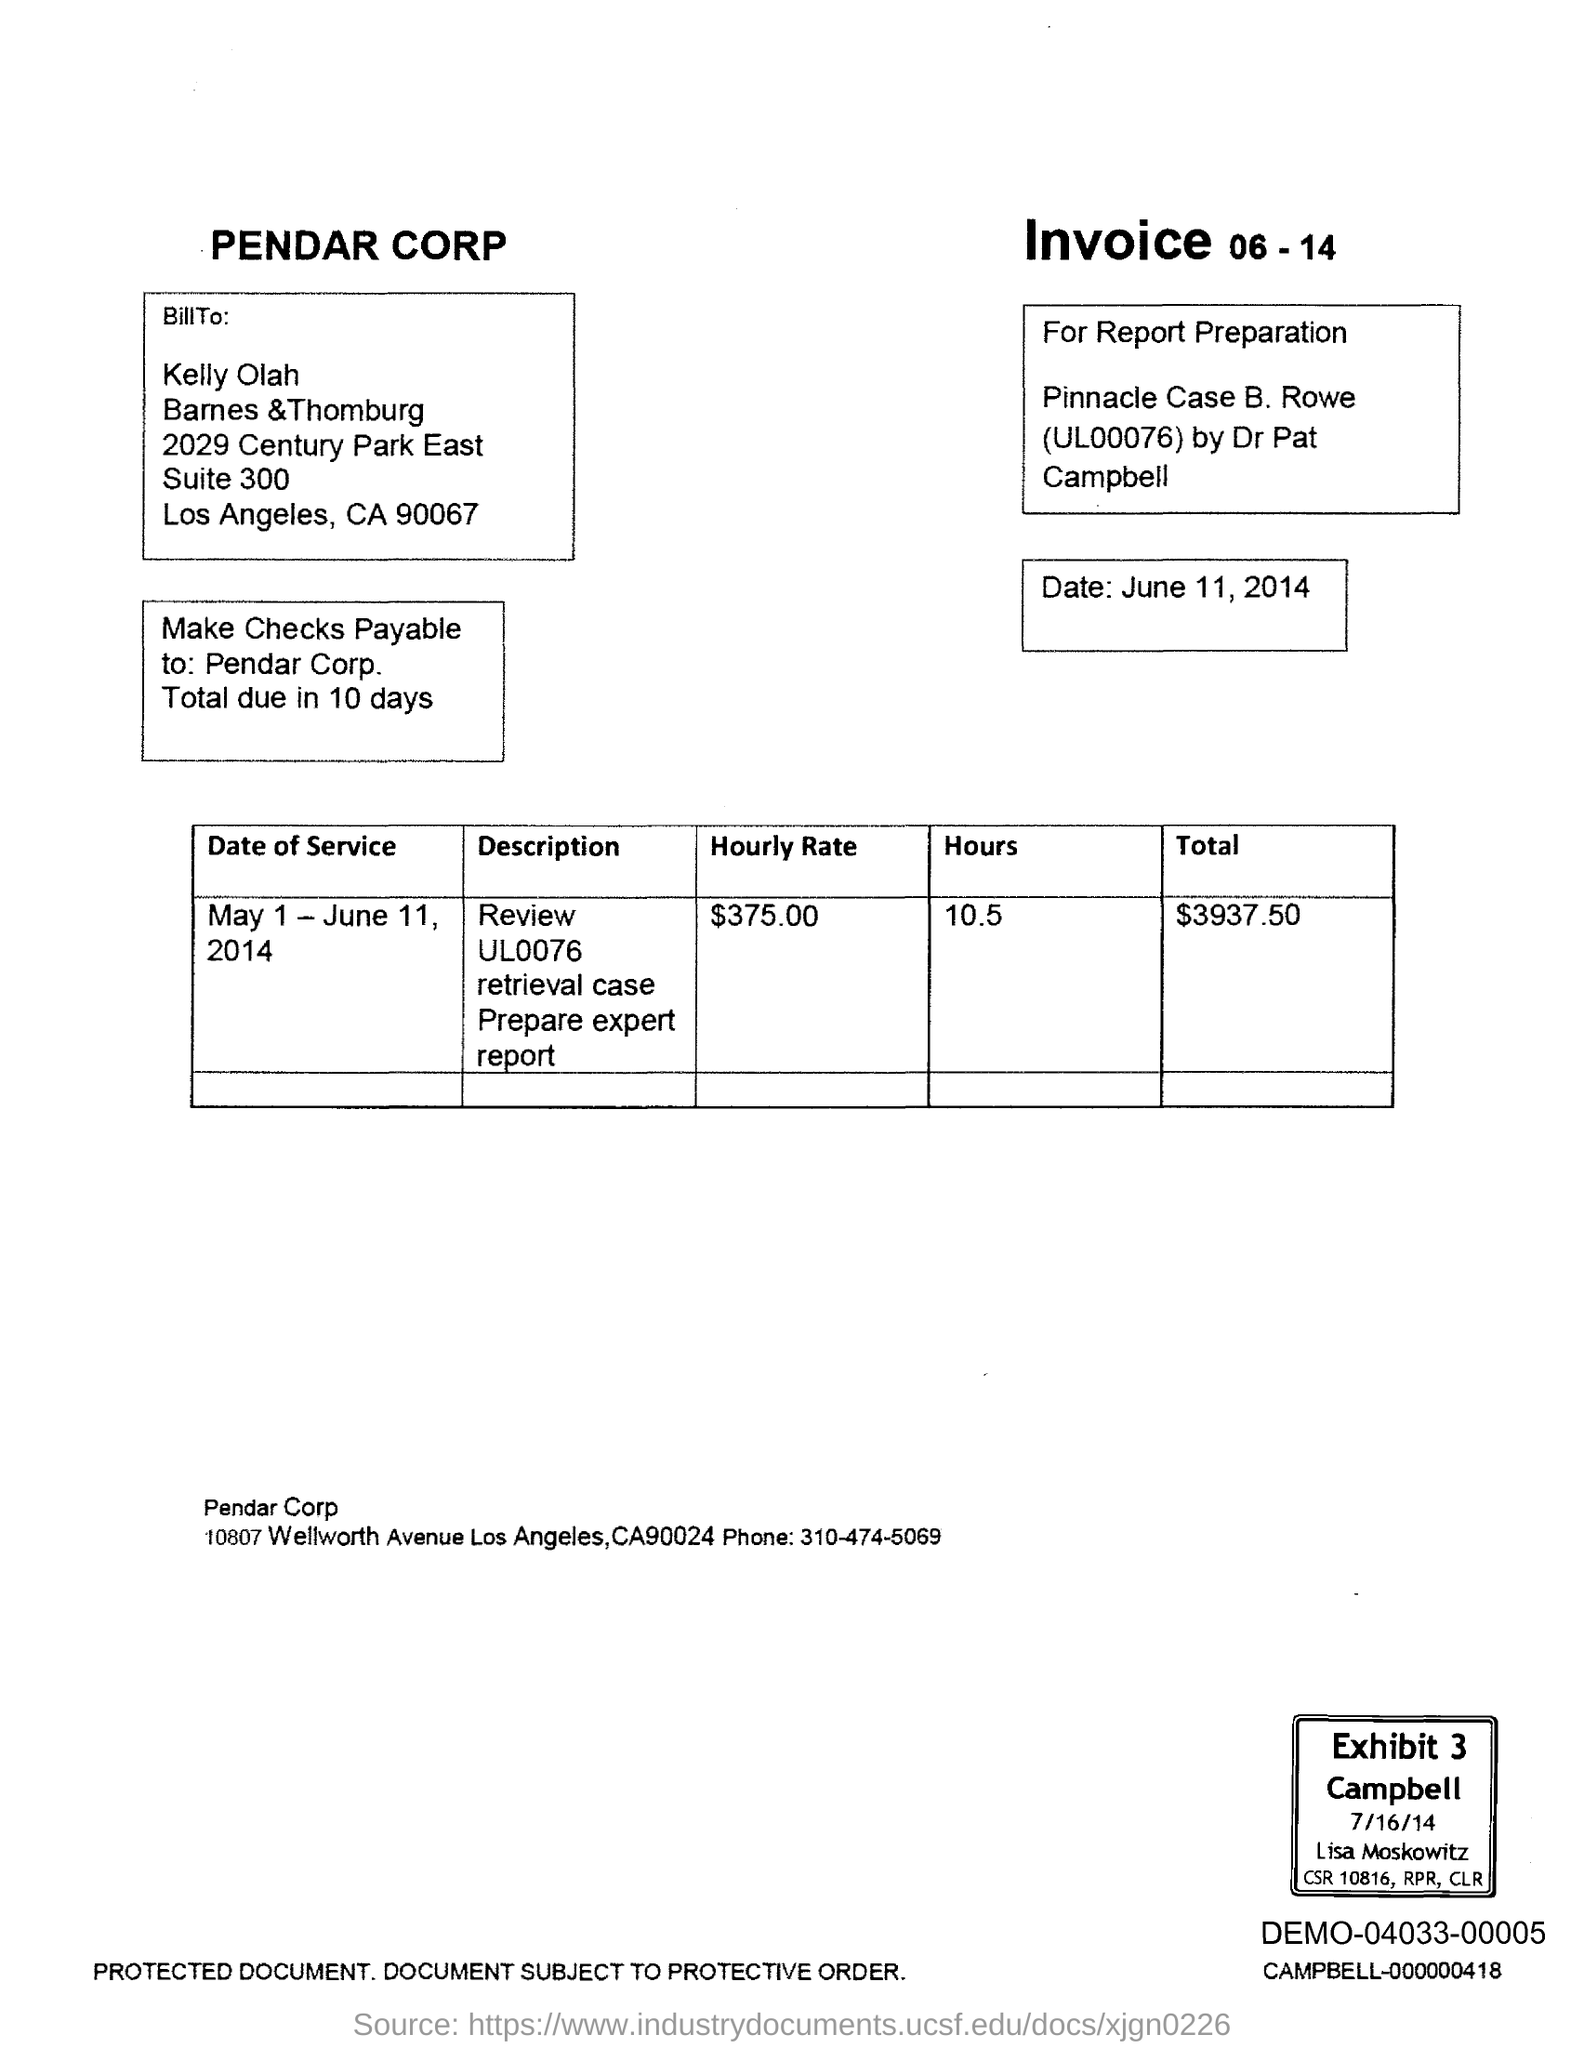Point out several critical features in this image. The hourly rate is $375.00. The total amount is $3937.50. Make checks payable to Pendar Corp. The current date is June 11, 2014. The date of service was from May 1 to June 11, 2014. 